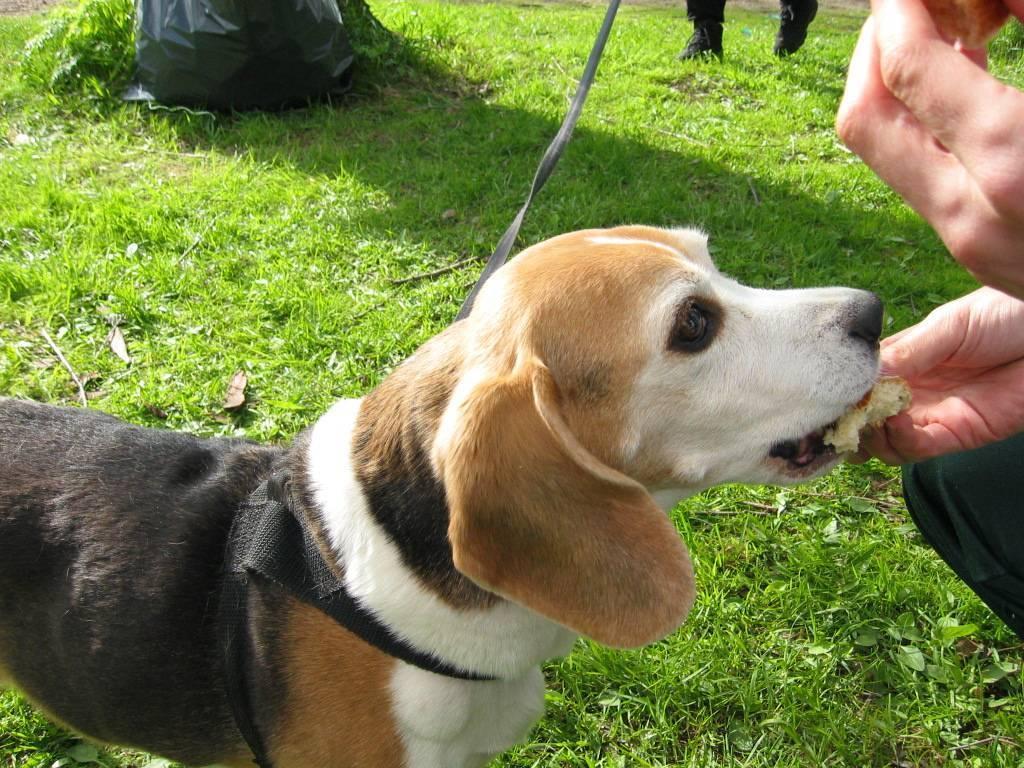Can you describe this image briefly? In this image we can see two persons and a dog, one person is feeding food to the dog, there is some grass and in the background there is a black color cover. 